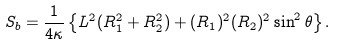Convert formula to latex. <formula><loc_0><loc_0><loc_500><loc_500>S _ { b } = { \frac { 1 } { 4 \kappa } } \left \{ L ^ { 2 } ( R _ { 1 } ^ { 2 } + R _ { 2 } ^ { 2 } ) + ( R _ { 1 } ) ^ { 2 } ( R _ { 2 } ) ^ { 2 } \sin ^ { 2 } \theta \right \} .</formula> 